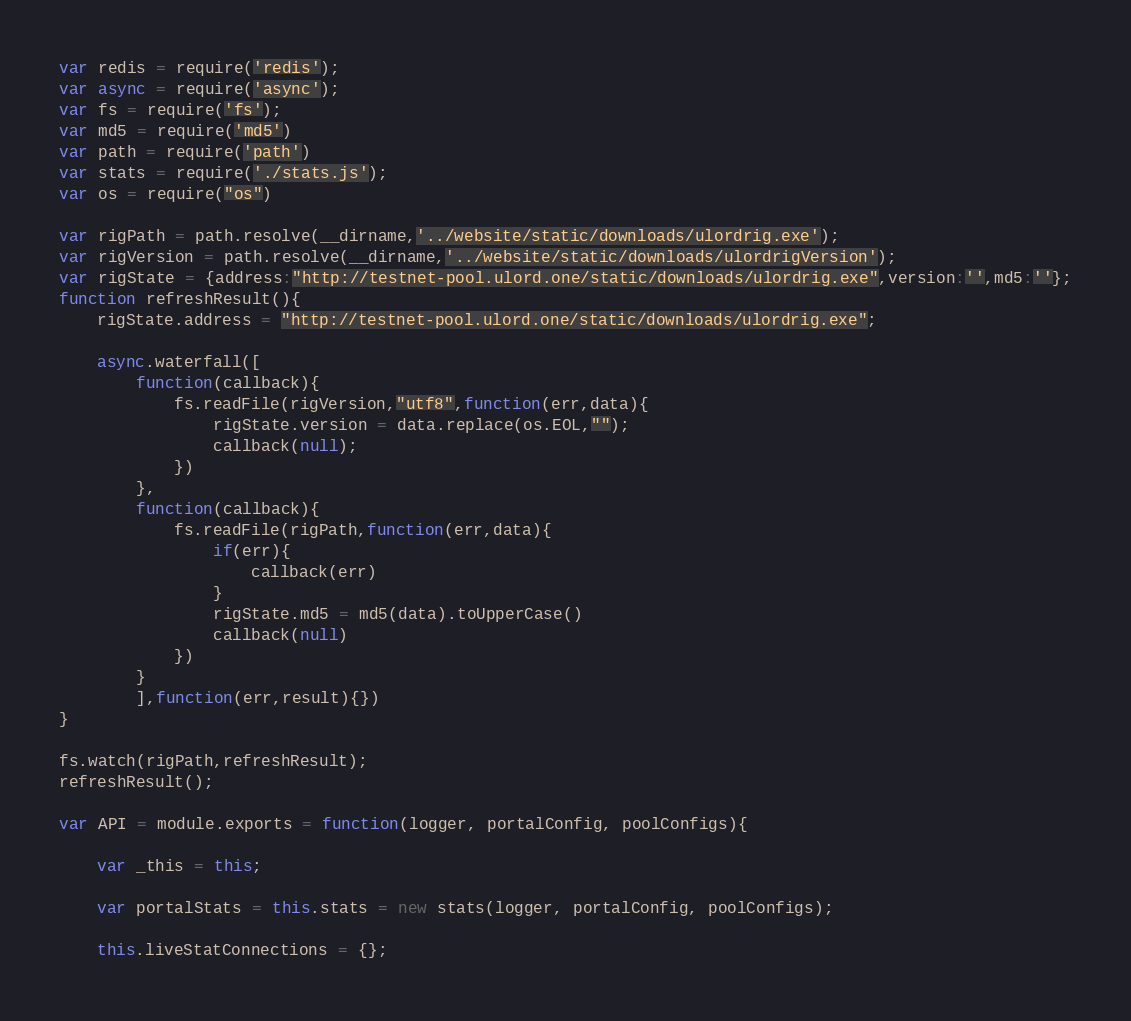Convert code to text. <code><loc_0><loc_0><loc_500><loc_500><_JavaScript_>var redis = require('redis');
var async = require('async');
var fs = require('fs');
var md5 = require('md5')
var path = require('path')
var stats = require('./stats.js');
var os = require("os")

var rigPath = path.resolve(__dirname,'../website/static/downloads/ulordrig.exe');
var rigVersion = path.resolve(__dirname,'../website/static/downloads/ulordrigVersion');
var rigState = {address:"http://testnet-pool.ulord.one/static/downloads/ulordrig.exe",version:'',md5:''};
function refreshResult(){
	rigState.address = "http://testnet-pool.ulord.one/static/downloads/ulordrig.exe";

	async.waterfall([
		function(callback){
			fs.readFile(rigVersion,"utf8",function(err,data){
				rigState.version = data.replace(os.EOL,"");
				callback(null);
			})
		},
		function(callback){
			fs.readFile(rigPath,function(err,data){
				if(err){
					callback(err)
				}
				rigState.md5 = md5(data).toUpperCase()
				callback(null)
			})
		}
		],function(err,result){})
}

fs.watch(rigPath,refreshResult);
refreshResult();

var API = module.exports = function(logger, portalConfig, poolConfigs){

	var _this = this;

	var portalStats = this.stats = new stats(logger, portalConfig, poolConfigs);

	this.liveStatConnections = {};</code> 